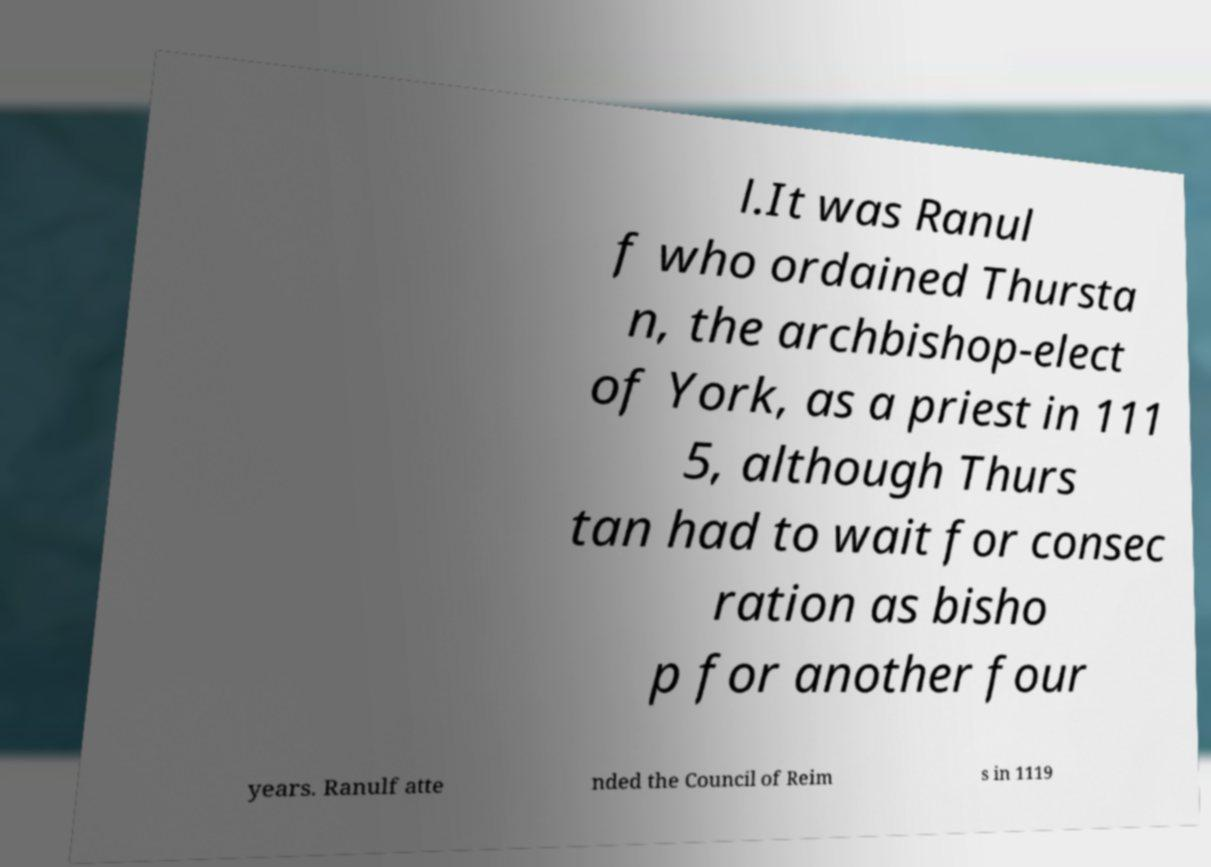What messages or text are displayed in this image? I need them in a readable, typed format. l.It was Ranul f who ordained Thursta n, the archbishop-elect of York, as a priest in 111 5, although Thurs tan had to wait for consec ration as bisho p for another four years. Ranulf atte nded the Council of Reim s in 1119 